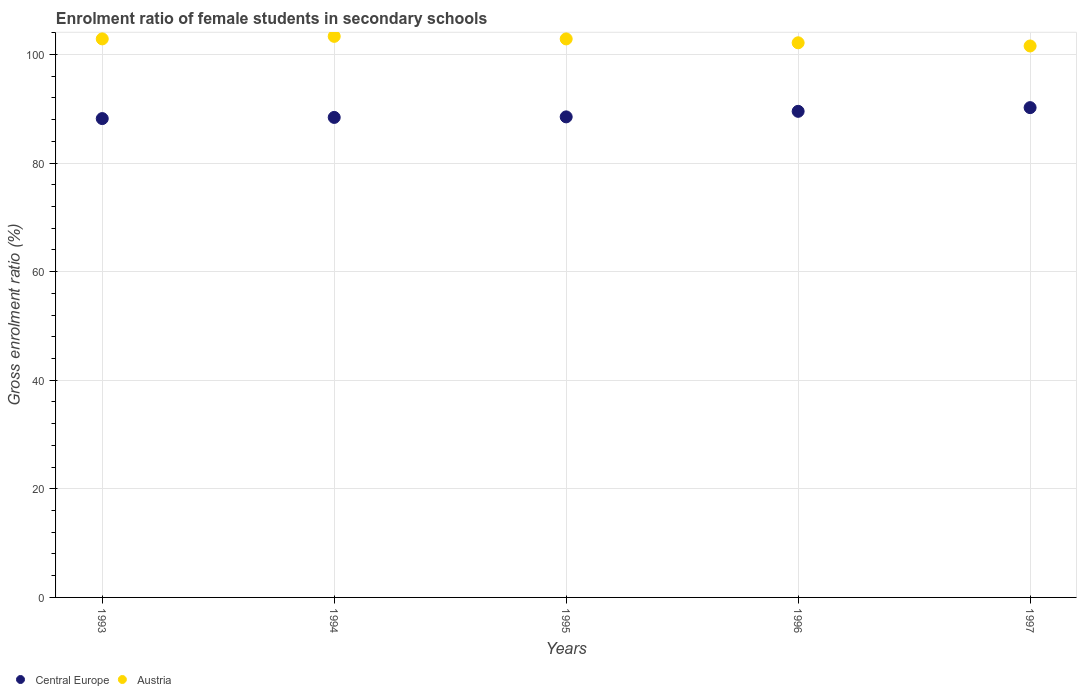Is the number of dotlines equal to the number of legend labels?
Provide a succinct answer. Yes. What is the enrolment ratio of female students in secondary schools in Central Europe in 1994?
Your response must be concise. 88.42. Across all years, what is the maximum enrolment ratio of female students in secondary schools in Central Europe?
Your answer should be compact. 90.22. Across all years, what is the minimum enrolment ratio of female students in secondary schools in Central Europe?
Your answer should be very brief. 88.2. In which year was the enrolment ratio of female students in secondary schools in Central Europe maximum?
Offer a terse response. 1997. In which year was the enrolment ratio of female students in secondary schools in Central Europe minimum?
Provide a short and direct response. 1993. What is the total enrolment ratio of female students in secondary schools in Austria in the graph?
Offer a very short reply. 512.84. What is the difference between the enrolment ratio of female students in secondary schools in Austria in 1995 and that in 1997?
Provide a succinct answer. 1.3. What is the difference between the enrolment ratio of female students in secondary schools in Central Europe in 1993 and the enrolment ratio of female students in secondary schools in Austria in 1997?
Provide a succinct answer. -13.37. What is the average enrolment ratio of female students in secondary schools in Central Europe per year?
Make the answer very short. 88.98. In the year 1993, what is the difference between the enrolment ratio of female students in secondary schools in Central Europe and enrolment ratio of female students in secondary schools in Austria?
Provide a succinct answer. -14.68. In how many years, is the enrolment ratio of female students in secondary schools in Austria greater than 68 %?
Your answer should be compact. 5. What is the ratio of the enrolment ratio of female students in secondary schools in Austria in 1993 to that in 1996?
Your answer should be very brief. 1.01. Is the enrolment ratio of female students in secondary schools in Austria in 1994 less than that in 1996?
Your response must be concise. No. Is the difference between the enrolment ratio of female students in secondary schools in Central Europe in 1994 and 1996 greater than the difference between the enrolment ratio of female students in secondary schools in Austria in 1994 and 1996?
Your answer should be compact. No. What is the difference between the highest and the second highest enrolment ratio of female students in secondary schools in Central Europe?
Provide a short and direct response. 0.68. What is the difference between the highest and the lowest enrolment ratio of female students in secondary schools in Austria?
Your response must be concise. 1.77. In how many years, is the enrolment ratio of female students in secondary schools in Austria greater than the average enrolment ratio of female students in secondary schools in Austria taken over all years?
Your answer should be very brief. 3. Does the enrolment ratio of female students in secondary schools in Central Europe monotonically increase over the years?
Make the answer very short. Yes. How many dotlines are there?
Offer a very short reply. 2. What is the difference between two consecutive major ticks on the Y-axis?
Give a very brief answer. 20. Are the values on the major ticks of Y-axis written in scientific E-notation?
Give a very brief answer. No. What is the title of the graph?
Provide a short and direct response. Enrolment ratio of female students in secondary schools. What is the label or title of the X-axis?
Provide a succinct answer. Years. What is the Gross enrolment ratio (%) in Central Europe in 1993?
Offer a very short reply. 88.2. What is the Gross enrolment ratio (%) of Austria in 1993?
Provide a succinct answer. 102.88. What is the Gross enrolment ratio (%) of Central Europe in 1994?
Your answer should be very brief. 88.42. What is the Gross enrolment ratio (%) in Austria in 1994?
Give a very brief answer. 103.35. What is the Gross enrolment ratio (%) in Central Europe in 1995?
Your answer should be very brief. 88.52. What is the Gross enrolment ratio (%) in Austria in 1995?
Give a very brief answer. 102.88. What is the Gross enrolment ratio (%) of Central Europe in 1996?
Keep it short and to the point. 89.54. What is the Gross enrolment ratio (%) in Austria in 1996?
Give a very brief answer. 102.16. What is the Gross enrolment ratio (%) of Central Europe in 1997?
Your response must be concise. 90.22. What is the Gross enrolment ratio (%) of Austria in 1997?
Your response must be concise. 101.58. Across all years, what is the maximum Gross enrolment ratio (%) in Central Europe?
Your answer should be very brief. 90.22. Across all years, what is the maximum Gross enrolment ratio (%) in Austria?
Offer a terse response. 103.35. Across all years, what is the minimum Gross enrolment ratio (%) of Central Europe?
Your answer should be very brief. 88.2. Across all years, what is the minimum Gross enrolment ratio (%) of Austria?
Make the answer very short. 101.58. What is the total Gross enrolment ratio (%) in Central Europe in the graph?
Give a very brief answer. 444.89. What is the total Gross enrolment ratio (%) in Austria in the graph?
Your answer should be very brief. 512.84. What is the difference between the Gross enrolment ratio (%) of Central Europe in 1993 and that in 1994?
Make the answer very short. -0.22. What is the difference between the Gross enrolment ratio (%) in Austria in 1993 and that in 1994?
Keep it short and to the point. -0.46. What is the difference between the Gross enrolment ratio (%) in Central Europe in 1993 and that in 1995?
Keep it short and to the point. -0.31. What is the difference between the Gross enrolment ratio (%) in Austria in 1993 and that in 1995?
Make the answer very short. 0.01. What is the difference between the Gross enrolment ratio (%) of Central Europe in 1993 and that in 1996?
Your answer should be compact. -1.34. What is the difference between the Gross enrolment ratio (%) of Austria in 1993 and that in 1996?
Provide a short and direct response. 0.72. What is the difference between the Gross enrolment ratio (%) of Central Europe in 1993 and that in 1997?
Give a very brief answer. -2.02. What is the difference between the Gross enrolment ratio (%) of Austria in 1993 and that in 1997?
Give a very brief answer. 1.31. What is the difference between the Gross enrolment ratio (%) in Central Europe in 1994 and that in 1995?
Provide a succinct answer. -0.1. What is the difference between the Gross enrolment ratio (%) in Austria in 1994 and that in 1995?
Offer a terse response. 0.47. What is the difference between the Gross enrolment ratio (%) of Central Europe in 1994 and that in 1996?
Provide a short and direct response. -1.12. What is the difference between the Gross enrolment ratio (%) in Austria in 1994 and that in 1996?
Offer a terse response. 1.19. What is the difference between the Gross enrolment ratio (%) of Central Europe in 1994 and that in 1997?
Offer a very short reply. -1.8. What is the difference between the Gross enrolment ratio (%) of Austria in 1994 and that in 1997?
Give a very brief answer. 1.77. What is the difference between the Gross enrolment ratio (%) of Central Europe in 1995 and that in 1996?
Your answer should be very brief. -1.02. What is the difference between the Gross enrolment ratio (%) of Austria in 1995 and that in 1996?
Offer a terse response. 0.71. What is the difference between the Gross enrolment ratio (%) in Central Europe in 1995 and that in 1997?
Your answer should be compact. -1.7. What is the difference between the Gross enrolment ratio (%) of Austria in 1995 and that in 1997?
Your response must be concise. 1.3. What is the difference between the Gross enrolment ratio (%) in Central Europe in 1996 and that in 1997?
Your response must be concise. -0.68. What is the difference between the Gross enrolment ratio (%) of Austria in 1996 and that in 1997?
Offer a terse response. 0.59. What is the difference between the Gross enrolment ratio (%) of Central Europe in 1993 and the Gross enrolment ratio (%) of Austria in 1994?
Give a very brief answer. -15.15. What is the difference between the Gross enrolment ratio (%) in Central Europe in 1993 and the Gross enrolment ratio (%) in Austria in 1995?
Keep it short and to the point. -14.68. What is the difference between the Gross enrolment ratio (%) in Central Europe in 1993 and the Gross enrolment ratio (%) in Austria in 1996?
Your response must be concise. -13.96. What is the difference between the Gross enrolment ratio (%) in Central Europe in 1993 and the Gross enrolment ratio (%) in Austria in 1997?
Offer a very short reply. -13.38. What is the difference between the Gross enrolment ratio (%) in Central Europe in 1994 and the Gross enrolment ratio (%) in Austria in 1995?
Offer a terse response. -14.46. What is the difference between the Gross enrolment ratio (%) in Central Europe in 1994 and the Gross enrolment ratio (%) in Austria in 1996?
Ensure brevity in your answer.  -13.74. What is the difference between the Gross enrolment ratio (%) of Central Europe in 1994 and the Gross enrolment ratio (%) of Austria in 1997?
Give a very brief answer. -13.16. What is the difference between the Gross enrolment ratio (%) of Central Europe in 1995 and the Gross enrolment ratio (%) of Austria in 1996?
Offer a very short reply. -13.65. What is the difference between the Gross enrolment ratio (%) in Central Europe in 1995 and the Gross enrolment ratio (%) in Austria in 1997?
Your answer should be very brief. -13.06. What is the difference between the Gross enrolment ratio (%) in Central Europe in 1996 and the Gross enrolment ratio (%) in Austria in 1997?
Keep it short and to the point. -12.04. What is the average Gross enrolment ratio (%) of Central Europe per year?
Your response must be concise. 88.98. What is the average Gross enrolment ratio (%) in Austria per year?
Your answer should be compact. 102.57. In the year 1993, what is the difference between the Gross enrolment ratio (%) in Central Europe and Gross enrolment ratio (%) in Austria?
Offer a very short reply. -14.68. In the year 1994, what is the difference between the Gross enrolment ratio (%) in Central Europe and Gross enrolment ratio (%) in Austria?
Offer a very short reply. -14.93. In the year 1995, what is the difference between the Gross enrolment ratio (%) in Central Europe and Gross enrolment ratio (%) in Austria?
Your answer should be compact. -14.36. In the year 1996, what is the difference between the Gross enrolment ratio (%) in Central Europe and Gross enrolment ratio (%) in Austria?
Ensure brevity in your answer.  -12.62. In the year 1997, what is the difference between the Gross enrolment ratio (%) of Central Europe and Gross enrolment ratio (%) of Austria?
Make the answer very short. -11.36. What is the ratio of the Gross enrolment ratio (%) of Central Europe in 1993 to that in 1994?
Offer a very short reply. 1. What is the ratio of the Gross enrolment ratio (%) of Central Europe in 1993 to that in 1995?
Your answer should be very brief. 1. What is the ratio of the Gross enrolment ratio (%) in Central Europe in 1993 to that in 1996?
Your response must be concise. 0.99. What is the ratio of the Gross enrolment ratio (%) of Austria in 1993 to that in 1996?
Offer a very short reply. 1.01. What is the ratio of the Gross enrolment ratio (%) in Central Europe in 1993 to that in 1997?
Your answer should be very brief. 0.98. What is the ratio of the Gross enrolment ratio (%) of Austria in 1993 to that in 1997?
Provide a succinct answer. 1.01. What is the ratio of the Gross enrolment ratio (%) in Central Europe in 1994 to that in 1996?
Your answer should be compact. 0.99. What is the ratio of the Gross enrolment ratio (%) of Austria in 1994 to that in 1996?
Ensure brevity in your answer.  1.01. What is the ratio of the Gross enrolment ratio (%) of Central Europe in 1994 to that in 1997?
Your answer should be compact. 0.98. What is the ratio of the Gross enrolment ratio (%) in Austria in 1994 to that in 1997?
Your response must be concise. 1.02. What is the ratio of the Gross enrolment ratio (%) in Central Europe in 1995 to that in 1996?
Ensure brevity in your answer.  0.99. What is the ratio of the Gross enrolment ratio (%) of Central Europe in 1995 to that in 1997?
Your answer should be very brief. 0.98. What is the ratio of the Gross enrolment ratio (%) of Austria in 1995 to that in 1997?
Ensure brevity in your answer.  1.01. What is the ratio of the Gross enrolment ratio (%) in Central Europe in 1996 to that in 1997?
Your response must be concise. 0.99. What is the ratio of the Gross enrolment ratio (%) of Austria in 1996 to that in 1997?
Give a very brief answer. 1.01. What is the difference between the highest and the second highest Gross enrolment ratio (%) of Central Europe?
Provide a succinct answer. 0.68. What is the difference between the highest and the second highest Gross enrolment ratio (%) of Austria?
Your response must be concise. 0.46. What is the difference between the highest and the lowest Gross enrolment ratio (%) of Central Europe?
Your response must be concise. 2.02. What is the difference between the highest and the lowest Gross enrolment ratio (%) in Austria?
Offer a very short reply. 1.77. 